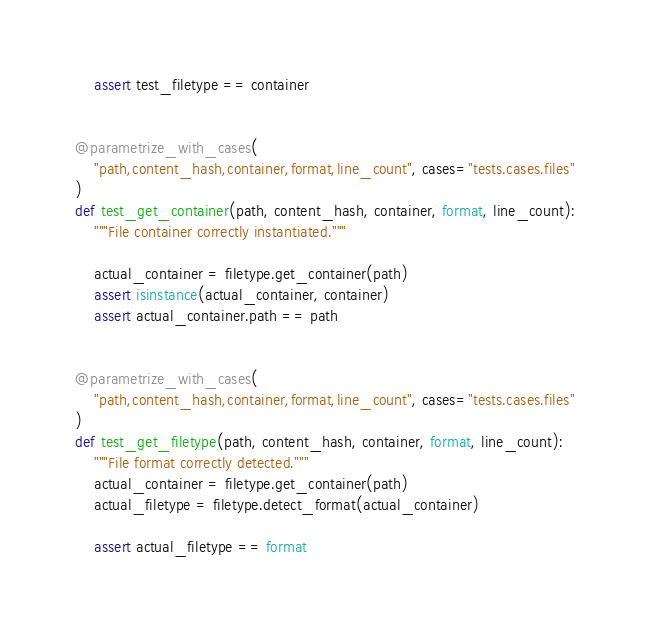<code> <loc_0><loc_0><loc_500><loc_500><_Python_>    assert test_filetype == container


@parametrize_with_cases(
    "path,content_hash,container,format,line_count", cases="tests.cases.files"
)
def test_get_container(path, content_hash, container, format, line_count):
    """File container correctly instantiated."""

    actual_container = filetype.get_container(path)
    assert isinstance(actual_container, container)
    assert actual_container.path == path


@parametrize_with_cases(
    "path,content_hash,container,format,line_count", cases="tests.cases.files"
)
def test_get_filetype(path, content_hash, container, format, line_count):
    """File format correctly detected."""
    actual_container = filetype.get_container(path)
    actual_filetype = filetype.detect_format(actual_container)

    assert actual_filetype == format
</code> 